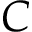Convert formula to latex. <formula><loc_0><loc_0><loc_500><loc_500>C</formula> 